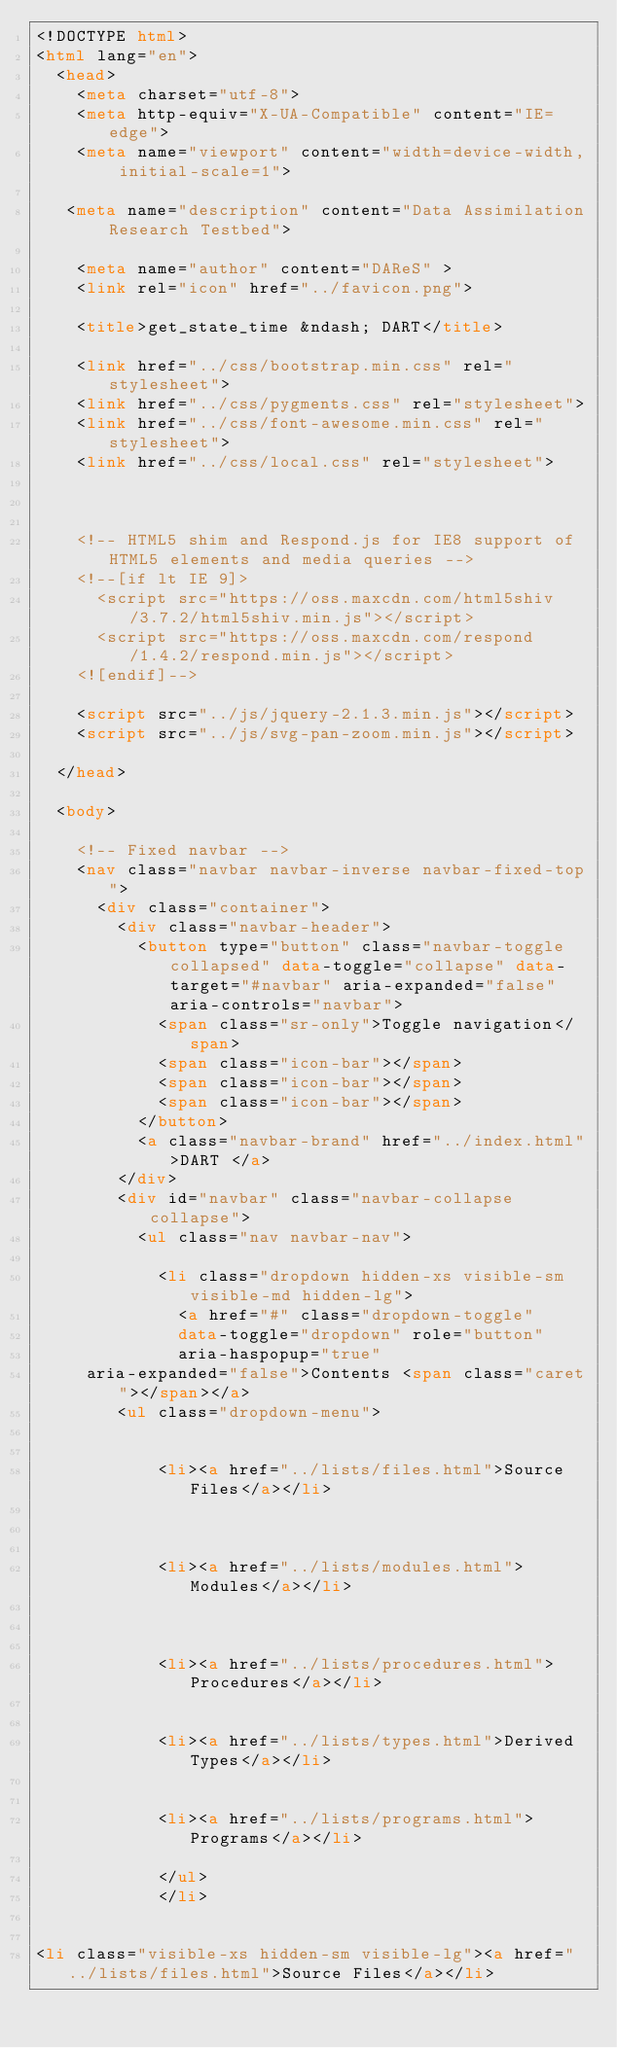<code> <loc_0><loc_0><loc_500><loc_500><_HTML_><!DOCTYPE html>
<html lang="en">
  <head>
    <meta charset="utf-8">
    <meta http-equiv="X-UA-Compatible" content="IE=edge">
    <meta name="viewport" content="width=device-width, initial-scale=1">
   
   <meta name="description" content="Data Assimilation Research Testbed">
    
    <meta name="author" content="DAReS" >
    <link rel="icon" href="../favicon.png">

    <title>get_state_time &ndash; DART</title>

    <link href="../css/bootstrap.min.css" rel="stylesheet">
    <link href="../css/pygments.css" rel="stylesheet">
    <link href="../css/font-awesome.min.css" rel="stylesheet">
    <link href="../css/local.css" rel="stylesheet">
    
    

    <!-- HTML5 shim and Respond.js for IE8 support of HTML5 elements and media queries -->
    <!--[if lt IE 9]>
      <script src="https://oss.maxcdn.com/html5shiv/3.7.2/html5shiv.min.js"></script>
      <script src="https://oss.maxcdn.com/respond/1.4.2/respond.min.js"></script>
    <![endif]-->
    
    <script src="../js/jquery-2.1.3.min.js"></script>
    <script src="../js/svg-pan-zoom.min.js"></script>

  </head>

  <body>

    <!-- Fixed navbar -->
    <nav class="navbar navbar-inverse navbar-fixed-top">
      <div class="container">
        <div class="navbar-header">
          <button type="button" class="navbar-toggle collapsed" data-toggle="collapse" data-target="#navbar" aria-expanded="false" aria-controls="navbar">
            <span class="sr-only">Toggle navigation</span>
            <span class="icon-bar"></span>
            <span class="icon-bar"></span>
            <span class="icon-bar"></span>
          </button>
          <a class="navbar-brand" href="../index.html">DART </a>
        </div>
        <div id="navbar" class="navbar-collapse collapse">
          <ul class="nav navbar-nav">
        
            <li class="dropdown hidden-xs visible-sm visible-md hidden-lg">
              <a href="#" class="dropdown-toggle"
              data-toggle="dropdown" role="button"
              aria-haspopup="true"
     aria-expanded="false">Contents <span class="caret"></span></a>
        <ul class="dropdown-menu">
          
              
            <li><a href="../lists/files.html">Source Files</a></li>
        
        
        
            <li><a href="../lists/modules.html">Modules</a></li>
        
            
                                
            <li><a href="../lists/procedures.html">Procedures</a></li>
        
               
            <li><a href="../lists/types.html">Derived Types</a></li>
        
        
            <li><a href="../lists/programs.html">Programs</a></li>
        
            </ul>
            </li>


<li class="visible-xs hidden-sm visible-lg"><a href="../lists/files.html">Source Files</a></li>


</code> 